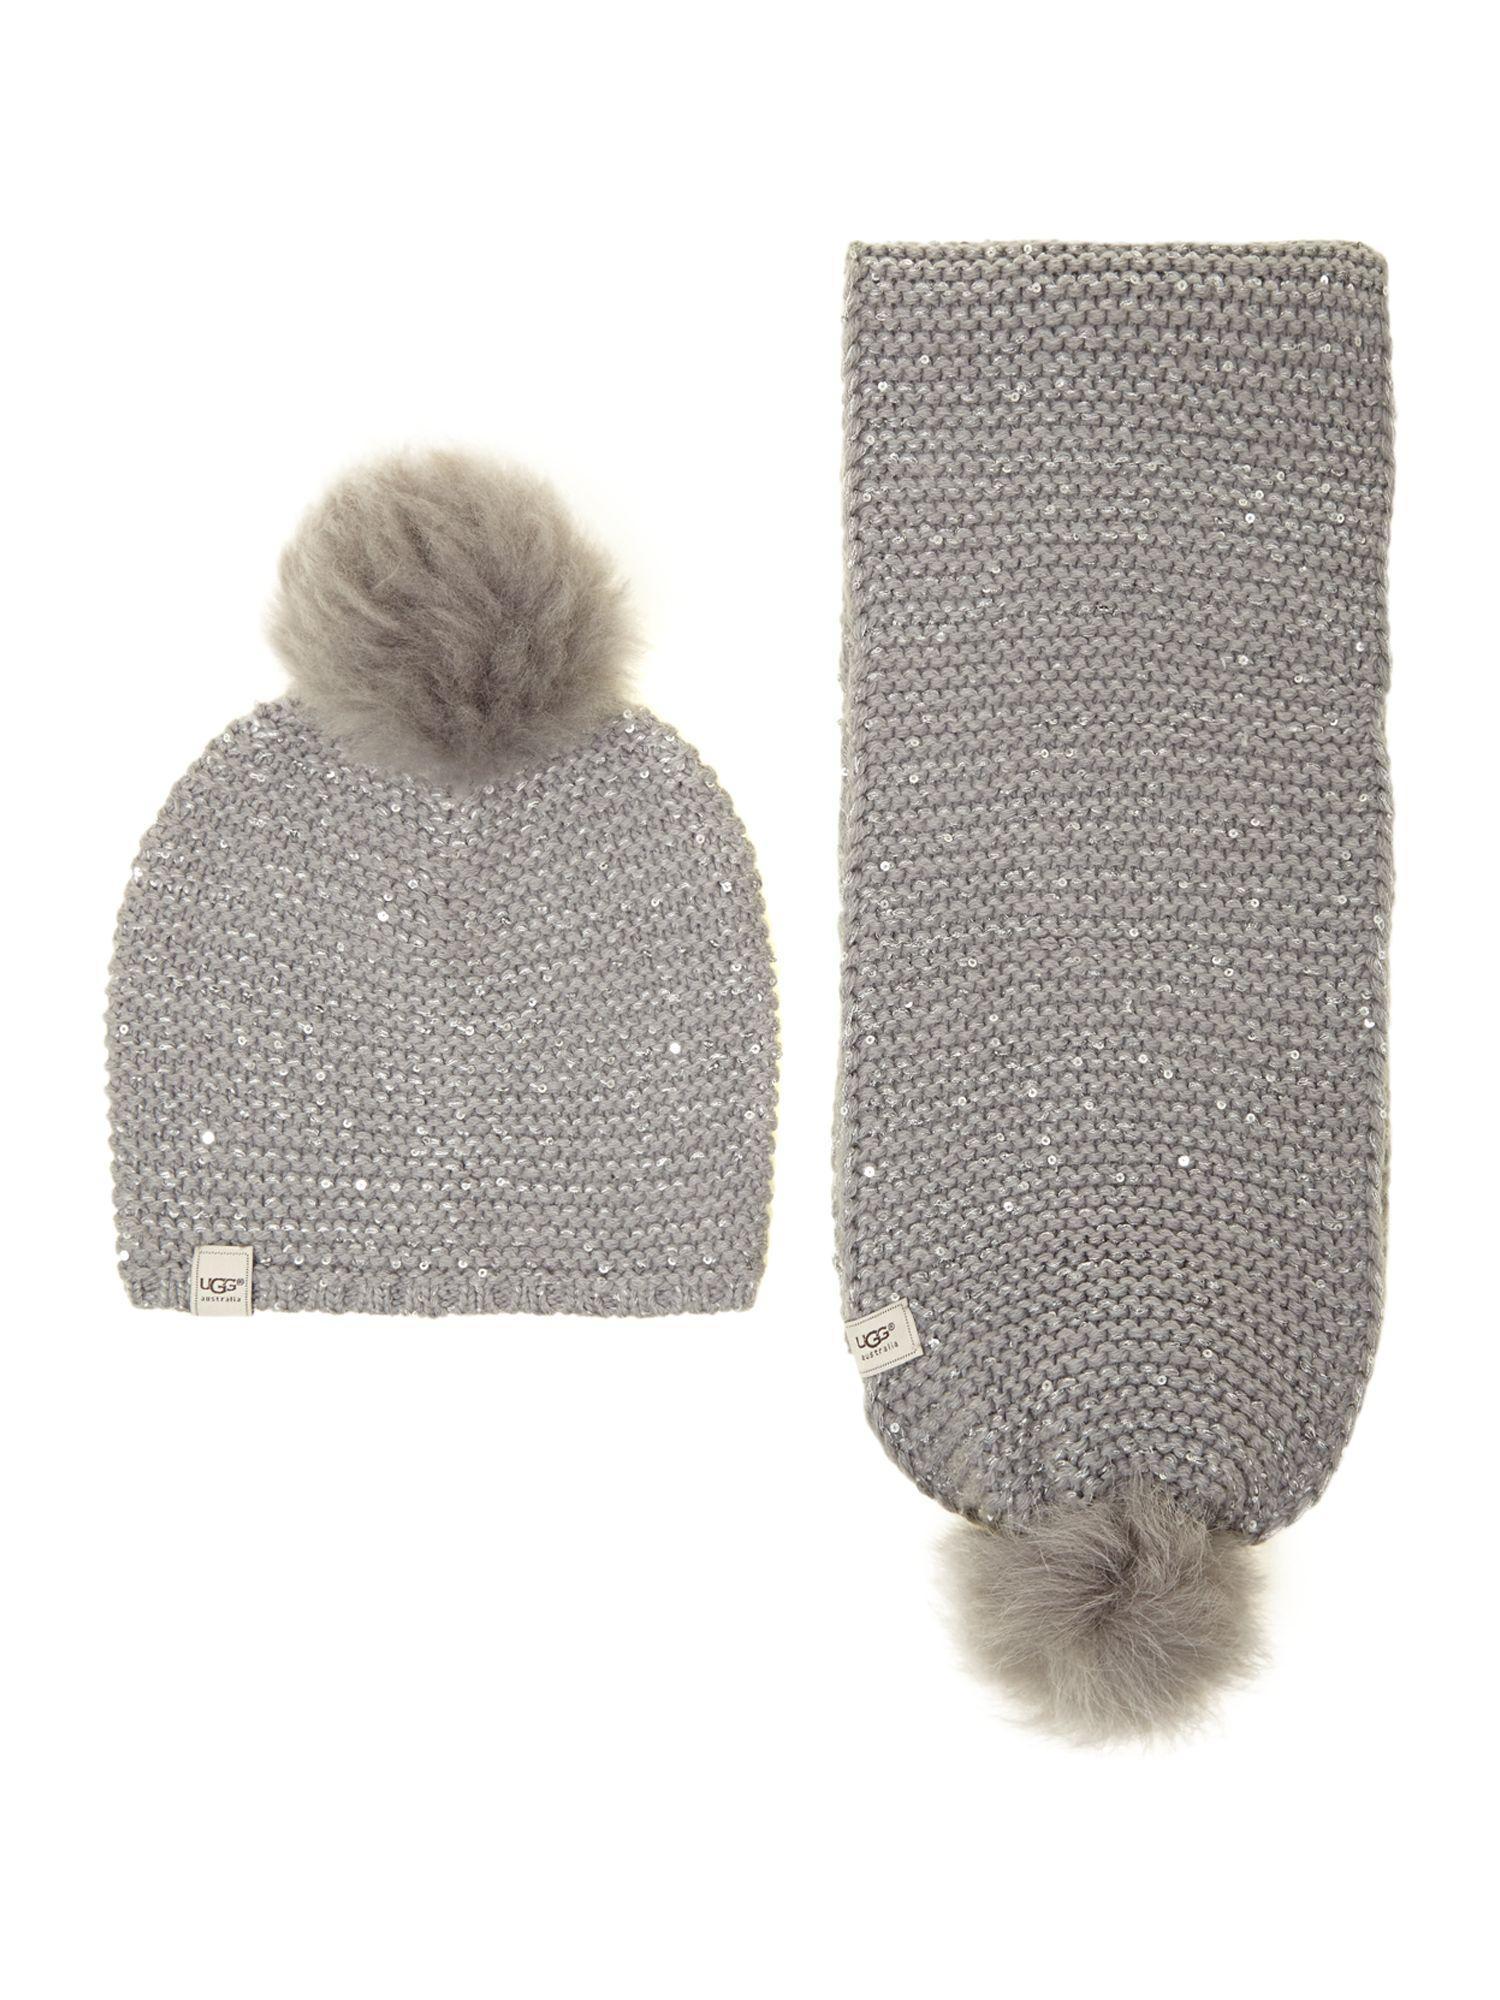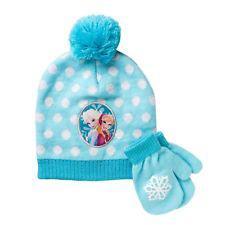The first image is the image on the left, the second image is the image on the right. Considering the images on both sides, is "One of the images contains a blue beanie with two blue gloves." valid? Answer yes or no. Yes. The first image is the image on the left, the second image is the image on the right. Given the left and right images, does the statement "One image shows a pair of mittens, not gloves, next to a blue cap with a pom-pom ball on top." hold true? Answer yes or no. Yes. 